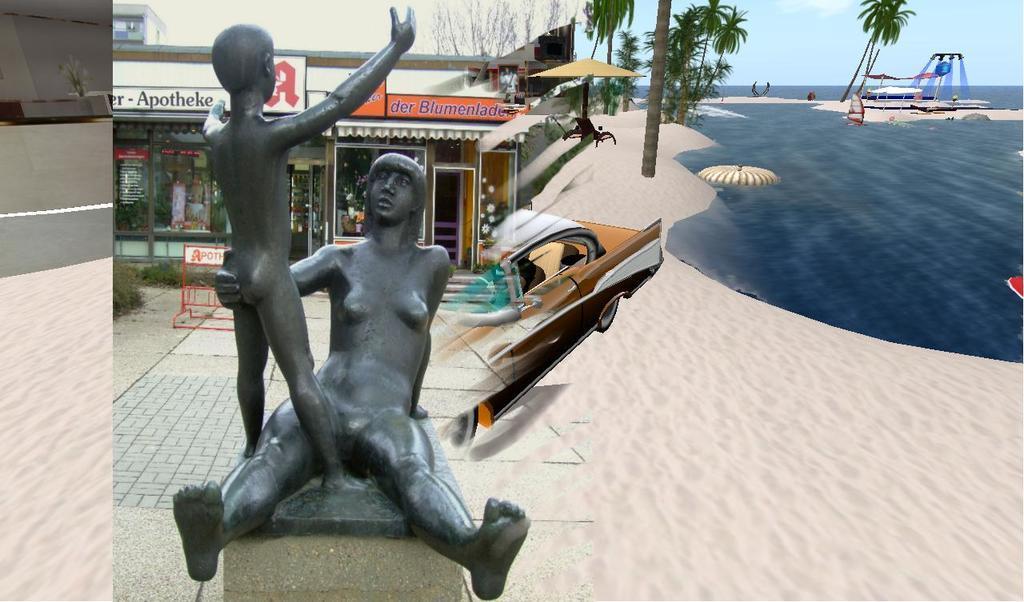In one or two sentences, can you explain what this image depicts? In this image, we can see a statue on the pillar. Here we can see shops, plants, banners and sky. On the right side and left side of the image, we can see an animated pictures. Here we can see car, trees, water, few objects and sky. 